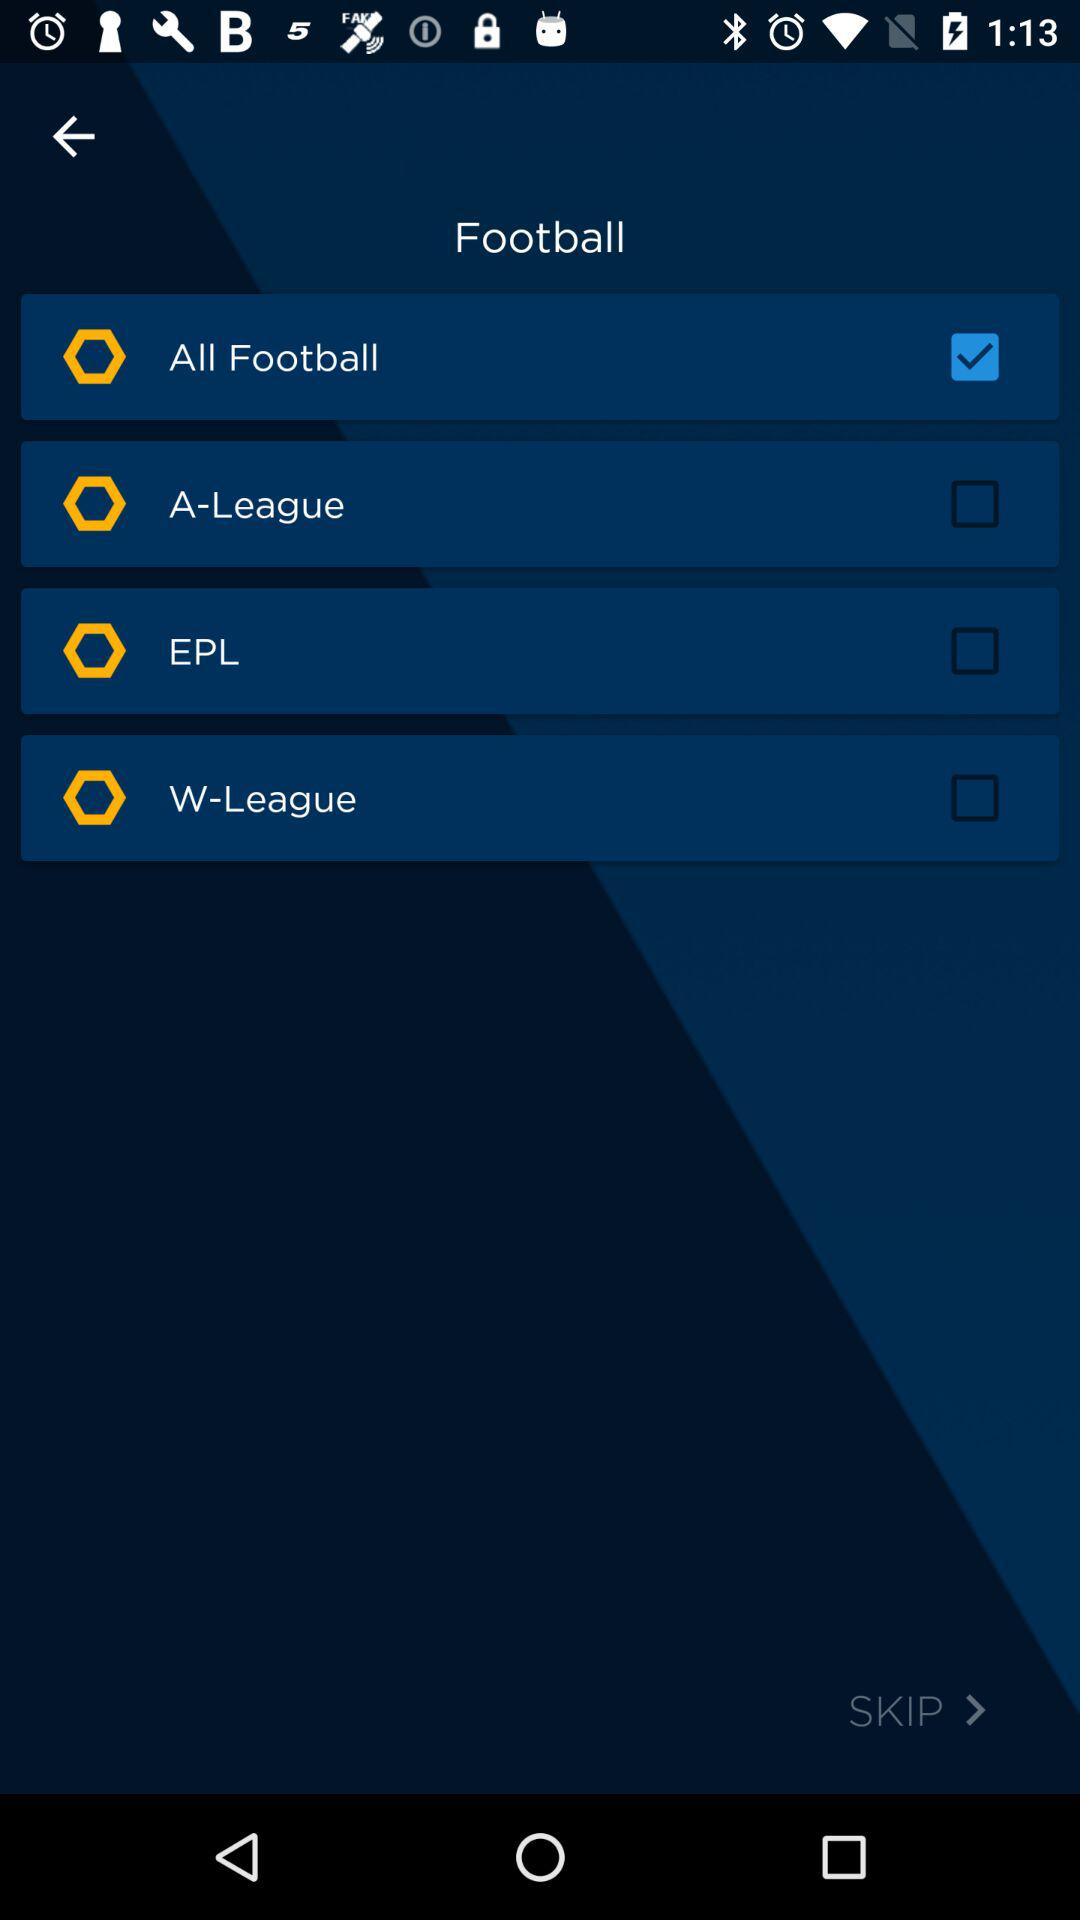What is the status of "EPL"? The status is "off". 